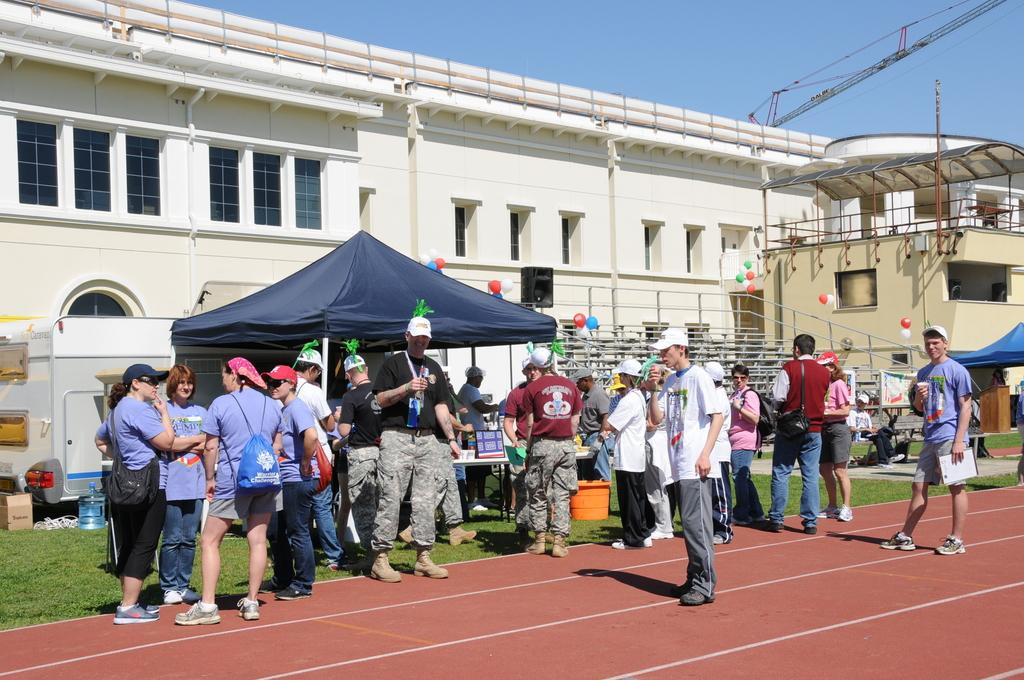What are the people in the image doing? There is a group of people standing on the ground in the image. What type of temporary shelters can be seen in the image? There are tents in the image. What decorative items are present in the image? Balloons are present in the image. What type of structures with openings for light and air can be seen in the image? There are buildings with windows in the image. What is used for watering plants or cleaning in the image? A water can is visible in the image. What items are used for carrying belongings in the image? Bags are present in the image. What piece of furniture is visible in the image? There is a table in the image. What can be seen in the background of the image? The sky is visible in the background of the image. How does the cast of a play perform in the image? There is no cast of a play present in the image; it features a group of people standing on the ground, tents, balloons, buildings, a water can, bags, a table, and a visible sky. What type of wave can be seen crashing on the shore in the image? There is no wave or shoreline present in the image; it features a group of people standing on the ground, tents, balloons, buildings, a water can, bags, a table, and a visible sky. 